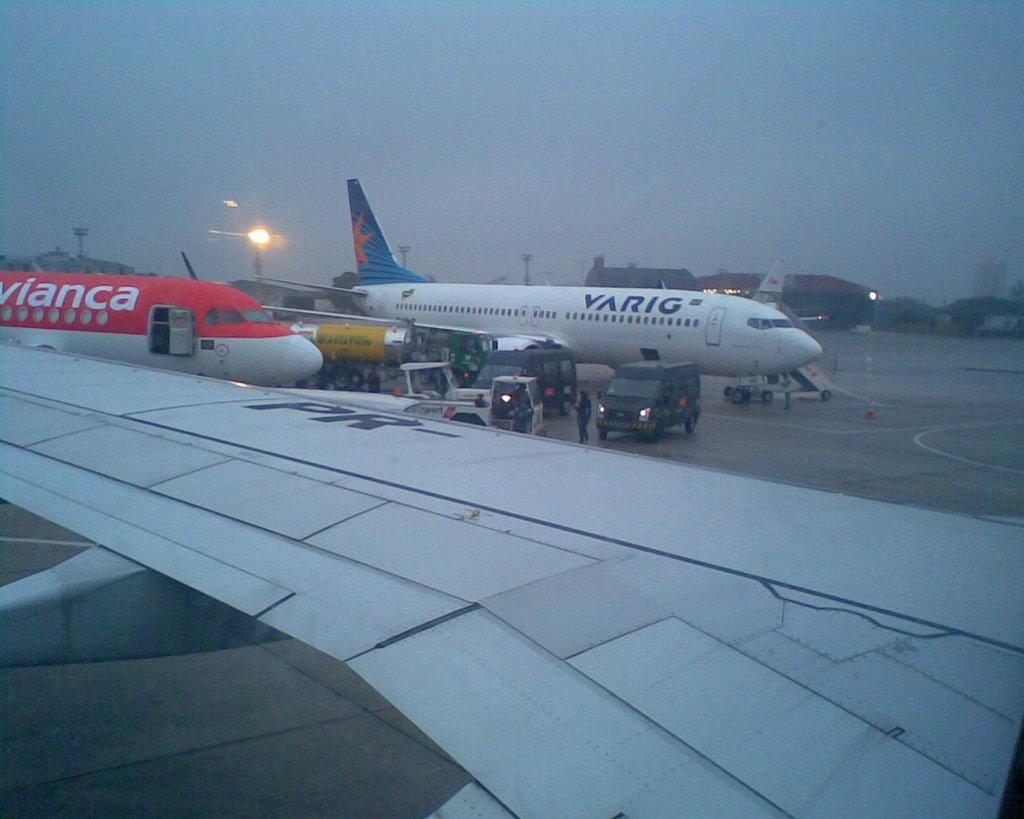In one or two sentences, can you explain what this image depicts? In this image we can see some airplanes, vehicles and there are some persons standing and in the background of the image there are some shed, lights and clear sky. 